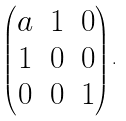Convert formula to latex. <formula><loc_0><loc_0><loc_500><loc_500>\begin{pmatrix} a & 1 & 0 \\ 1 & 0 & 0 \\ 0 & 0 & 1 \end{pmatrix} .</formula> 